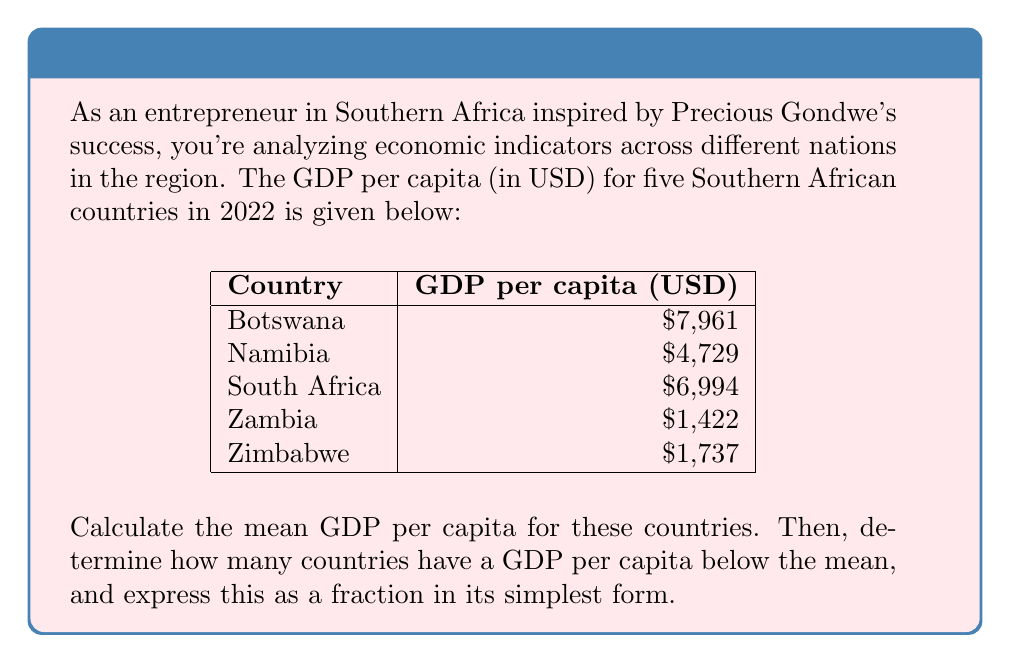Provide a solution to this math problem. 1. Calculate the mean GDP per capita:
   $$\text{Mean} = \frac{\text{Sum of all values}}{\text{Number of values}}$$
   $$\text{Mean} = \frac{7961 + 4729 + 6994 + 1422 + 1737}{5} = \frac{22843}{5} = 4568.6$$

2. Compare each country's GDP per capita to the mean:
   - Botswana: $7961 > 4568.6$
   - Namibia: $4729 > 4568.6$
   - South Africa: $6994 > 4568.6$
   - Zambia: $1422 < 4568.6$
   - Zimbabwe: $1737 < 4568.6$

3. Count the number of countries below the mean:
   2 countries (Zambia and Zimbabwe) are below the mean.

4. Express this as a fraction:
   $$\frac{\text{Countries below mean}}{\text{Total countries}} = \frac{2}{5}$$

5. The fraction $\frac{2}{5}$ is already in its simplest form.
Answer: $\frac{2}{5}$ 